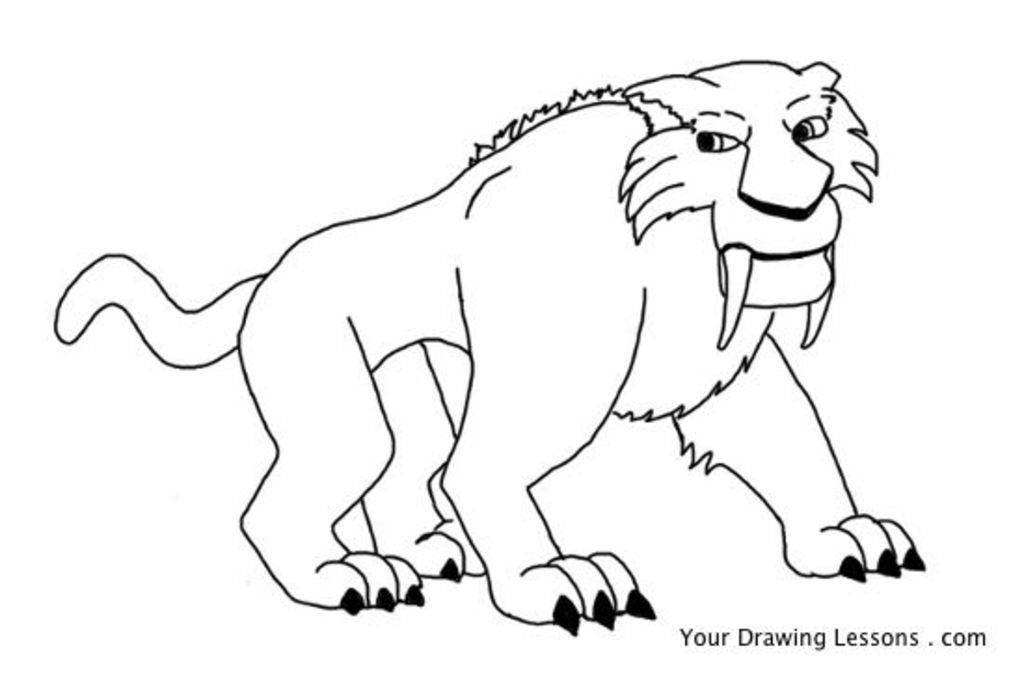What is the main subject of the image? The main subject of the image is a printing page. What is depicted on the printing page? The printing page features a lion. Can you tell me how many beads are used to create the lion on the printing page? There is no mention of beads or any crafting materials in the image. The lion is depicted on a printing page, which suggests it is a printed image rather than a beaded creation. 